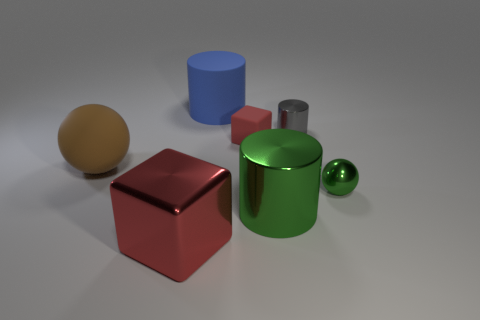Add 3 gray cylinders. How many objects exist? 10 Subtract all spheres. How many objects are left? 5 Add 2 brown things. How many brown things are left? 3 Add 4 brown rubber things. How many brown rubber things exist? 5 Subtract 1 gray cylinders. How many objects are left? 6 Subtract all green cylinders. Subtract all small red rubber cubes. How many objects are left? 5 